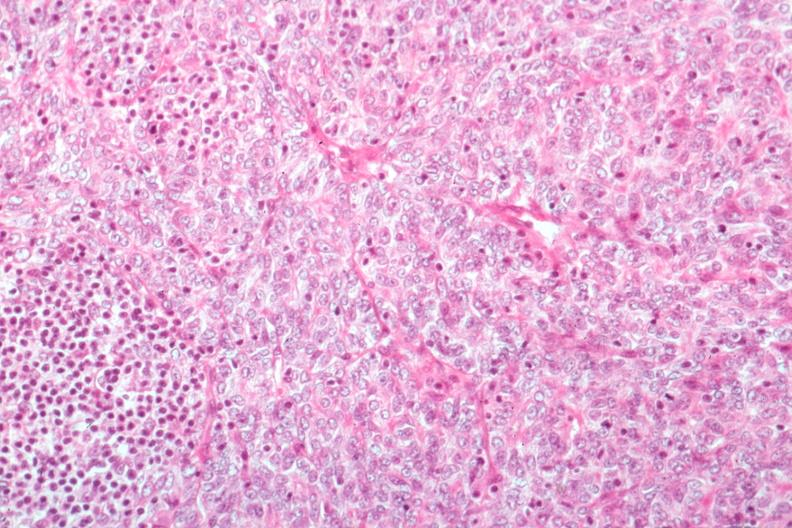s thymoma present?
Answer the question using a single word or phrase. Yes 